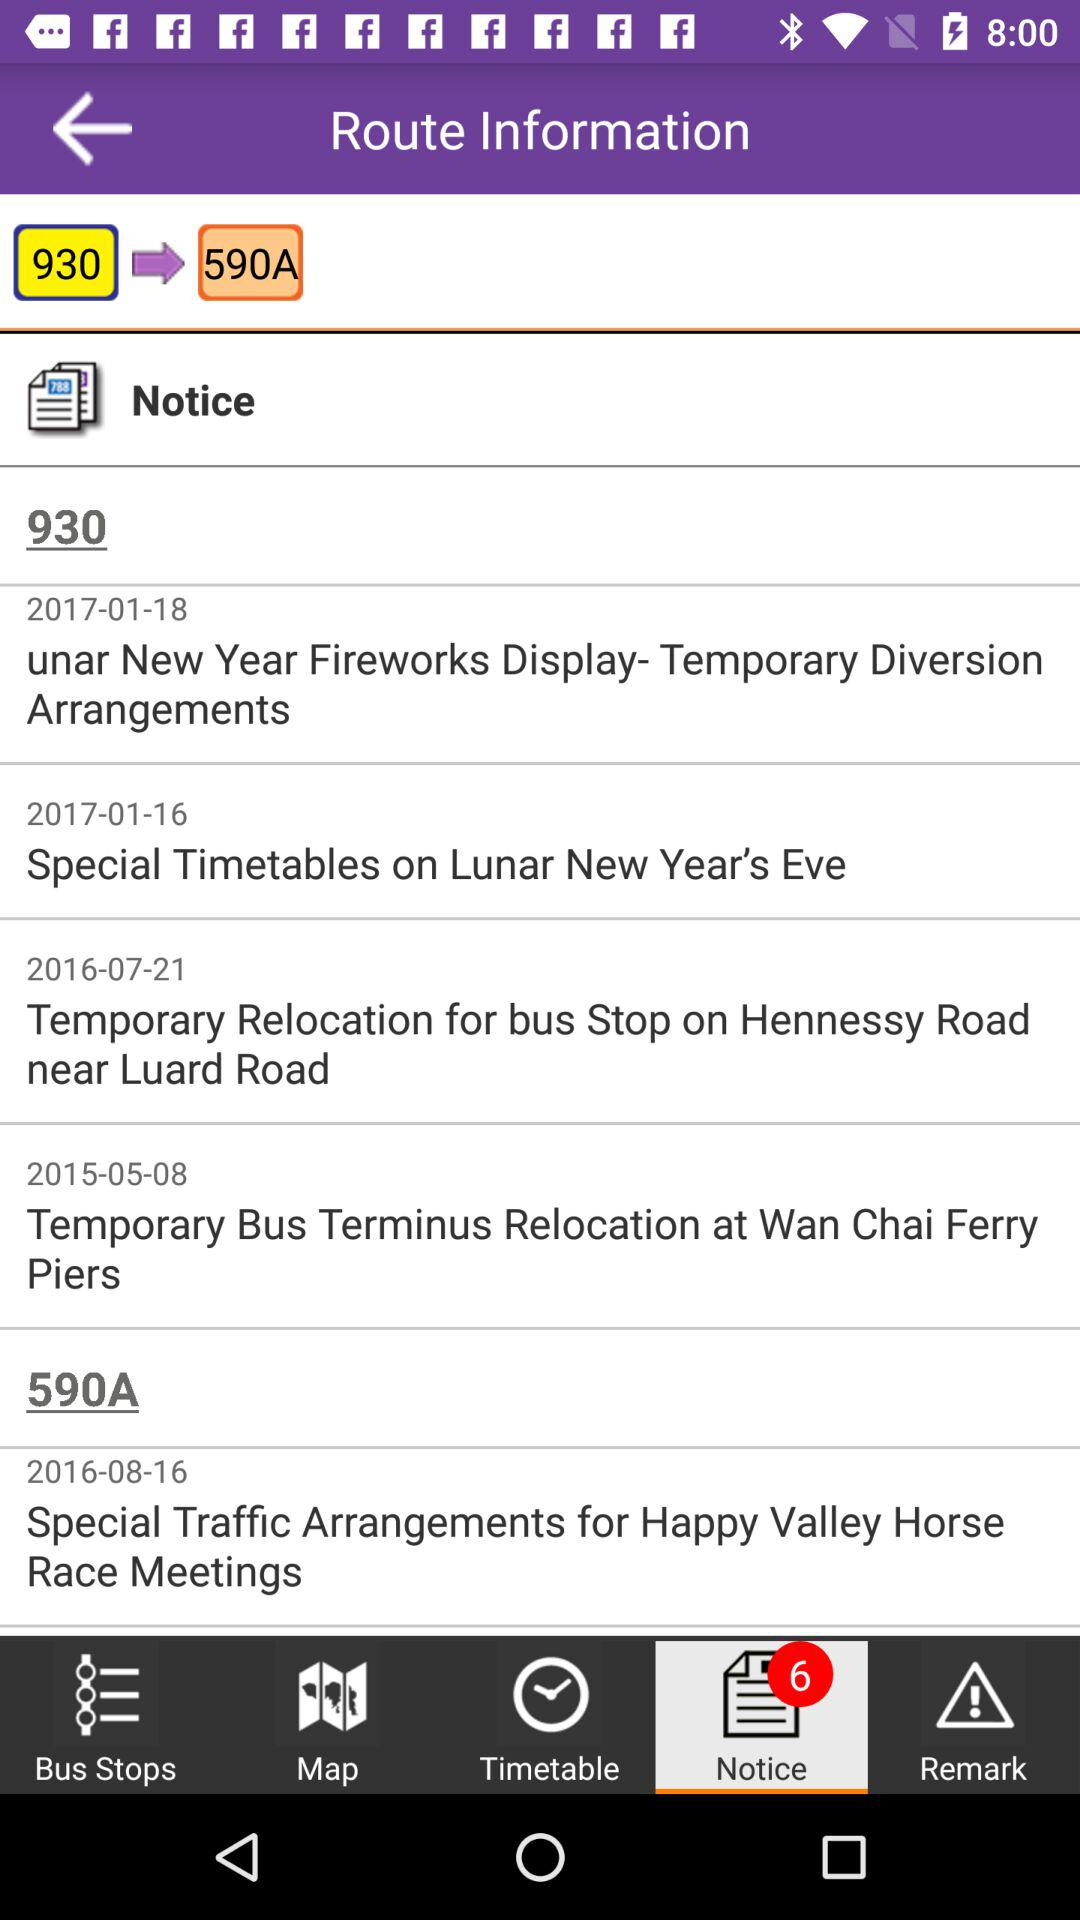What was the notice on 2015-05-08? The notice was "Temporary Bus Terminus Relocation at Wan Chai Ferry Piers". 